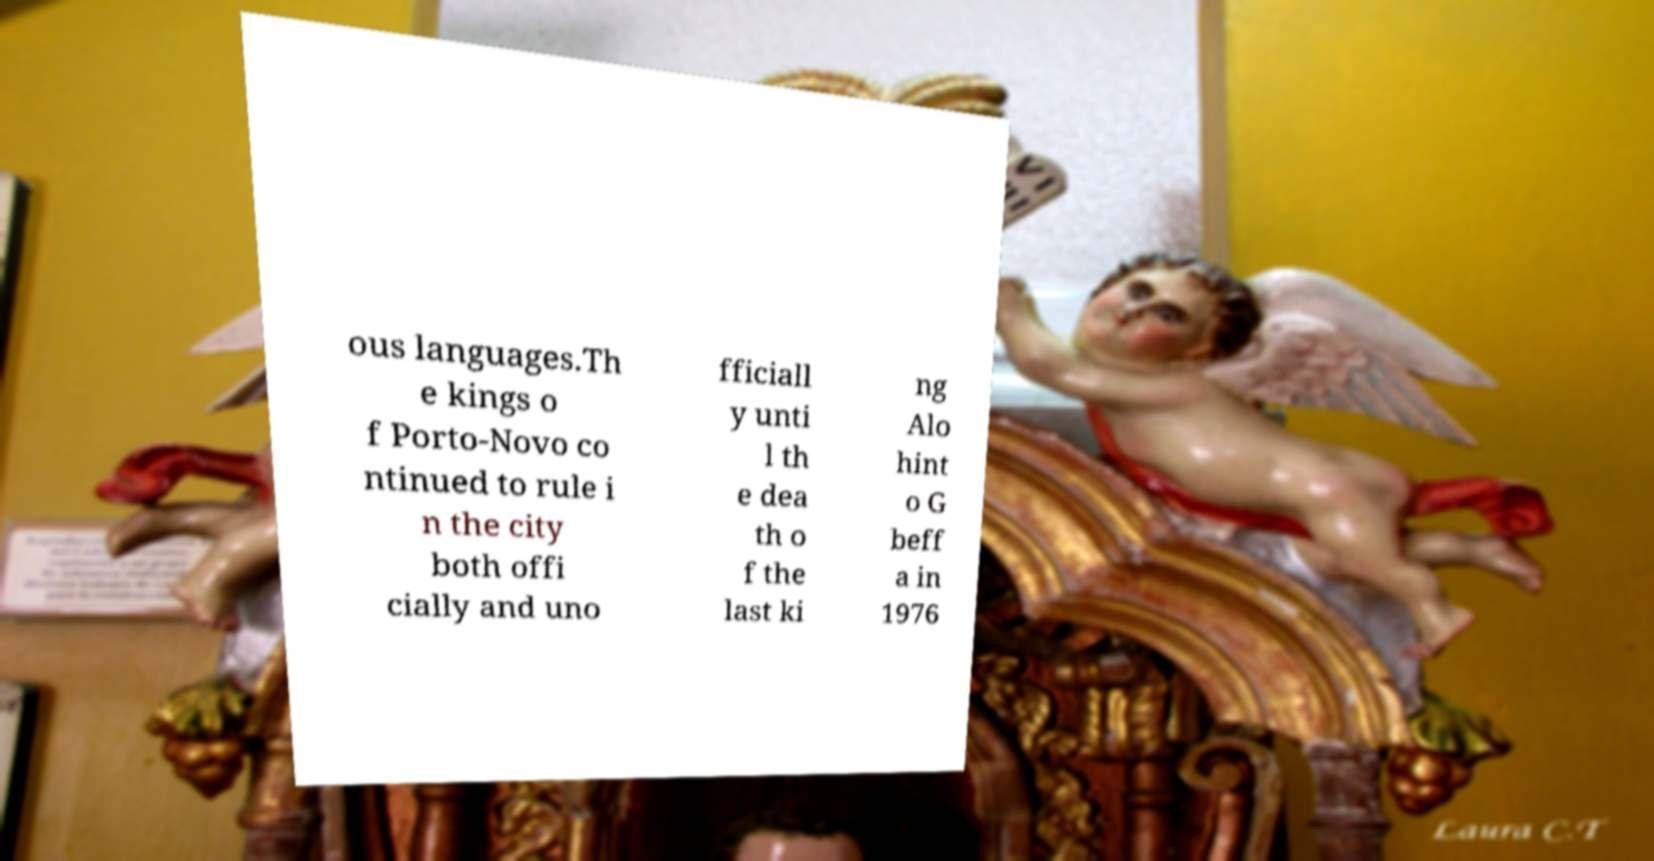What messages or text are displayed in this image? I need them in a readable, typed format. ous languages.Th e kings o f Porto-Novo co ntinued to rule i n the city both offi cially and uno fficiall y unti l th e dea th o f the last ki ng Alo hint o G beff a in 1976 